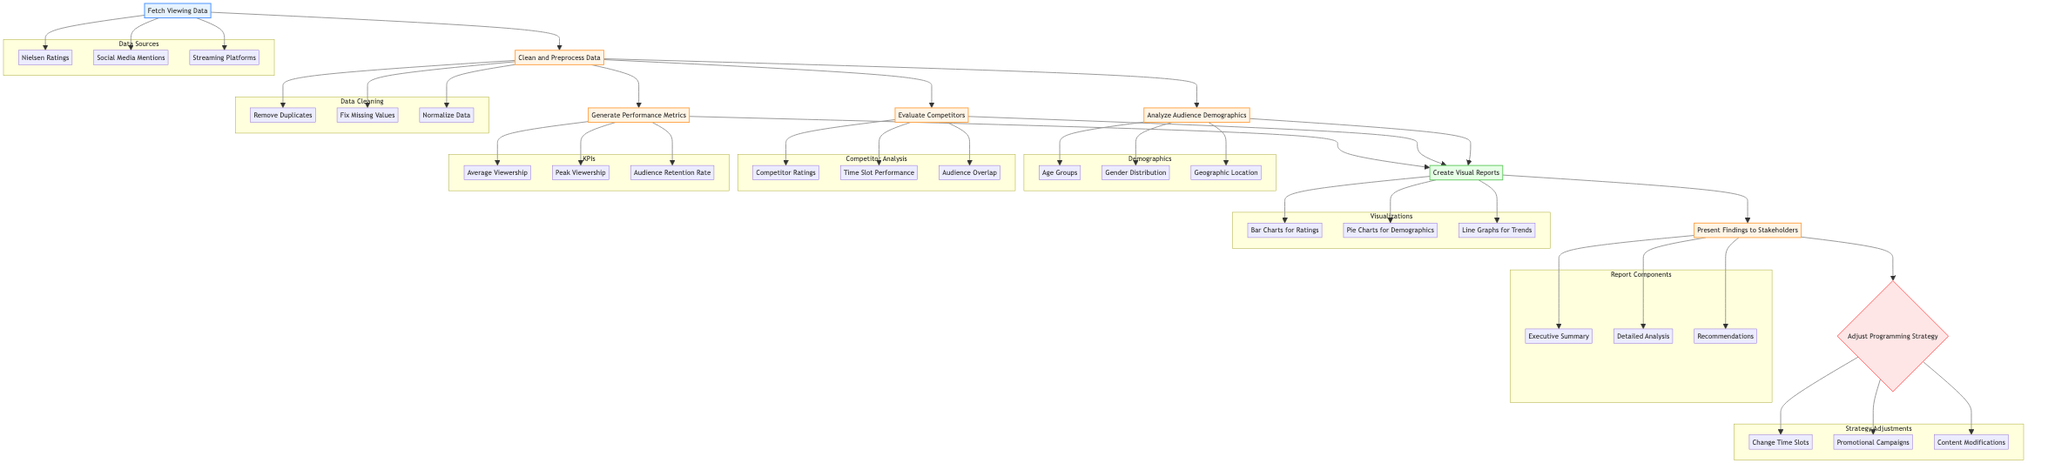What is the first step in the flowchart? The first step in the flowchart is labeled "Fetch Viewing Data." This indicates it is the starting point of the process where data gathering occurs.
Answer: Fetch Viewing Data How many main processing steps are in the diagram? The main processing steps, which include cleaning data, analyzing demographics, evaluating competitors, and generating performance metrics, total four distinct processes.
Answer: 4 Which node leads to the creation of visual reports? The nodes that lead to creating visual reports are the three processes: Analyze Audience Demographics, Evaluate Competitors, and Generate Performance Metrics. These three converge into the "Create Visual Reports" step.
Answer: Analyze Audience Demographics, Evaluate Competitors, Generate Performance Metrics What is the purpose of the "Adjust Programming Strategy" decision node? This node indicates a decision point where programming strategy should be adjusted based on the analysis of the previous findings, which influences show scheduling, promotions, and content modifications.
Answer: Adjust programming strategy How are competitors evaluated according to the diagram? Competitor evaluation consists of analyzing the Competitor Ratings, Time Slot Performance, and Audience Overlap, each of which provides insight into how well the show is performing relative to its competition.
Answer: Competitor Ratings, Time Slot Performance, Audience Overlap What are the output elements generated from the performance analysis? The output elements include visual reports that consist of Bar Charts for Ratings, Pie Charts for Demographics, and Line Graphs for Trends, organizing the analyzed data into visual formats for clearer communication.
Answer: Bar Charts for Ratings, Pie Charts for Demographics, Line Graphs for Trends Which process step receives input from the "Clean and Preprocess Data" step? The steps that receive input from "Clean and Preprocess Data" are Analyze Audience Demographics, Evaluate Competitors, and Generate Performance Metrics, as all these processes build upon the cleaned data to derive insights.
Answer: Analyze Audience Demographics, Evaluate Competitors, Generate Performance Metrics What type of information is gathered during the "Fetch Viewing Data" step? This step gathers various types of information including Nielsen Ratings, Social Media Mentions, and Streaming Platforms data to form a comprehensive understanding of viewing habits.
Answer: Nielsen Ratings, Social Media Mentions, Streaming Platforms Which node follows the creation of visual reports in the flowchart? After the creation of visual reports, the next step is to "Present Findings to Stakeholders," ensuring that the insights garnered from the reports are communicated effectively to interested parties.
Answer: Present Findings to Stakeholders 